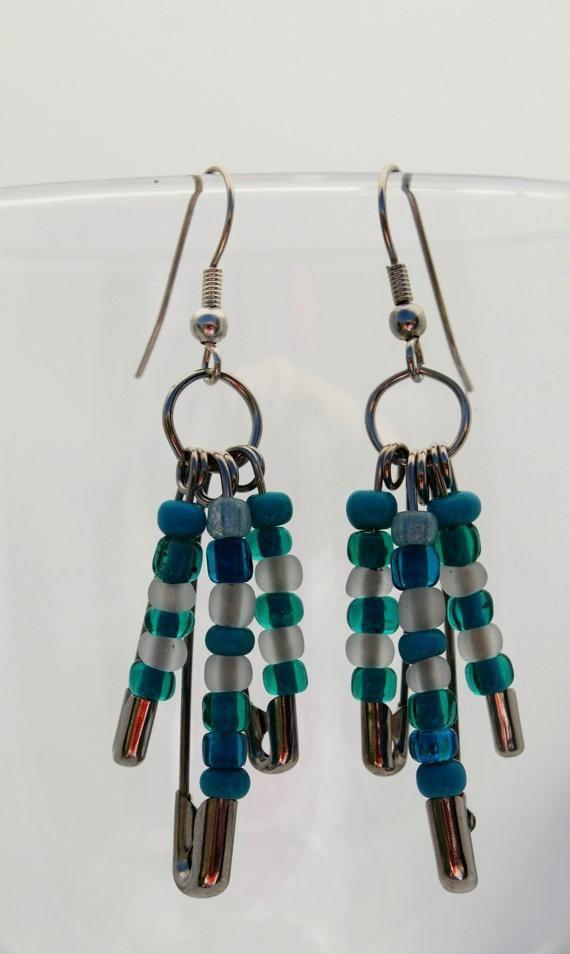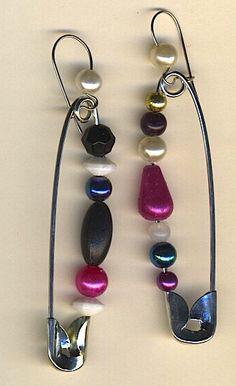The first image is the image on the left, the second image is the image on the right. Considering the images on both sides, is "There are no less than three plain safety pins without any beads" valid? Answer yes or no. No. The first image is the image on the left, the second image is the image on the right. Examine the images to the left and right. Is the description "There is one pin in the right image." accurate? Answer yes or no. No. 